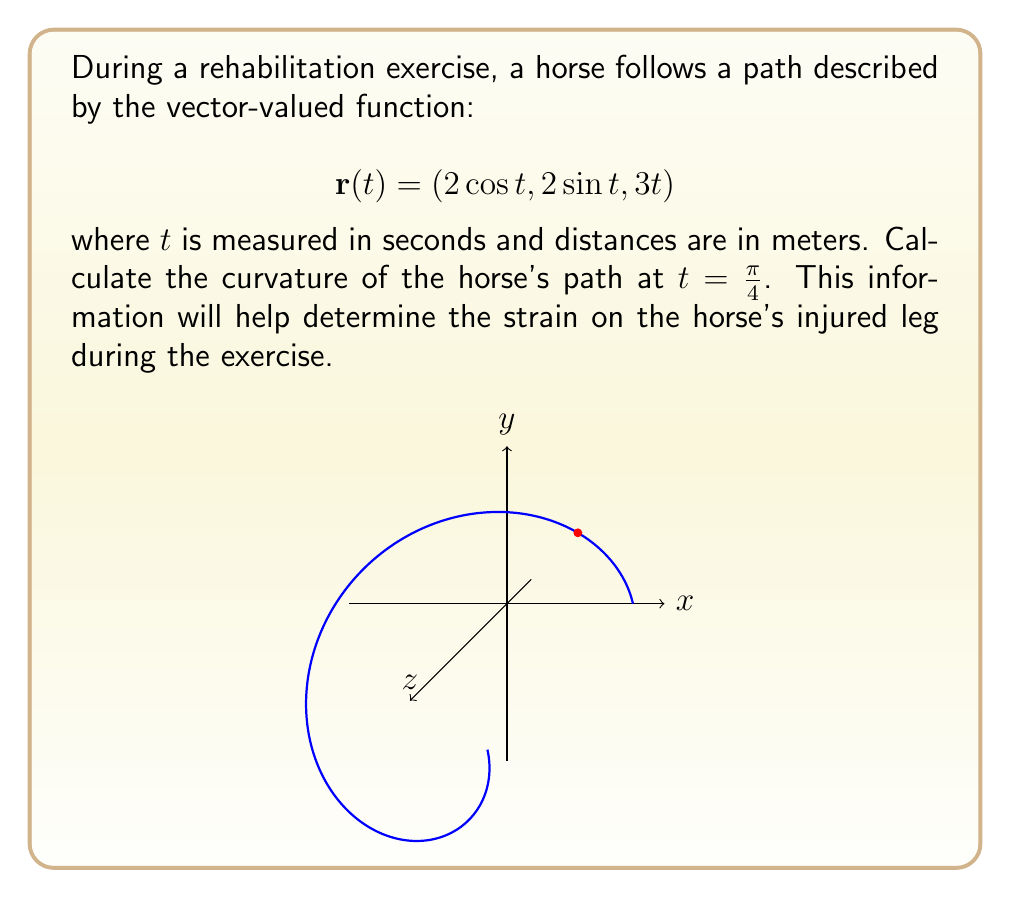Help me with this question. To calculate the curvature of the horse's path, we'll use the formula:

$$\kappa = \frac{|\mathbf{r}'(t) \times \mathbf{r}''(t)|}{|\mathbf{r}'(t)|^3}$$

Step 1: Calculate $\mathbf{r}'(t)$
$$\mathbf{r}'(t) = (-2\sin t, 2\cos t, 3)$$

Step 2: Calculate $\mathbf{r}''(t)$
$$\mathbf{r}''(t) = (-2\cos t, -2\sin t, 0)$$

Step 3: Calculate $\mathbf{r}'(t) \times \mathbf{r}''(t)$
$$\begin{align*}
\mathbf{r}'(t) \times \mathbf{r}''(t) &= \begin{vmatrix}
\mathbf{i} & \mathbf{j} & \mathbf{k} \\
-2\sin t & 2\cos t & 3 \\
-2\cos t & -2\sin t & 0
\end{vmatrix} \\
&= (-6\sin t)\mathbf{i} + (-6\cos t)\mathbf{j} + (-4)\mathbf{k}
\end{align*}$$

Step 4: Calculate $|\mathbf{r}'(t) \times \mathbf{r}''(t)|$
$$|\mathbf{r}'(t) \times \mathbf{r}''(t)| = \sqrt{36\sin^2 t + 36\cos^2 t + 16} = \sqrt{52}$$

Step 5: Calculate $|\mathbf{r}'(t)|$
$$|\mathbf{r}'(t)| = \sqrt{4\sin^2 t + 4\cos^2 t + 9} = \sqrt{13}$$

Step 6: Apply the curvature formula at $t = \frac{\pi}{4}$
$$\kappa = \frac{|\mathbf{r}'(t) \times \mathbf{r}''(t)|}{|\mathbf{r}'(t)|^3} = \frac{\sqrt{52}}{(\sqrt{13})^3} = \frac{\sqrt{52}}{13\sqrt{13}}$$
Answer: $\frac{\sqrt{52}}{13\sqrt{13}}$ m$^{-1}$ 